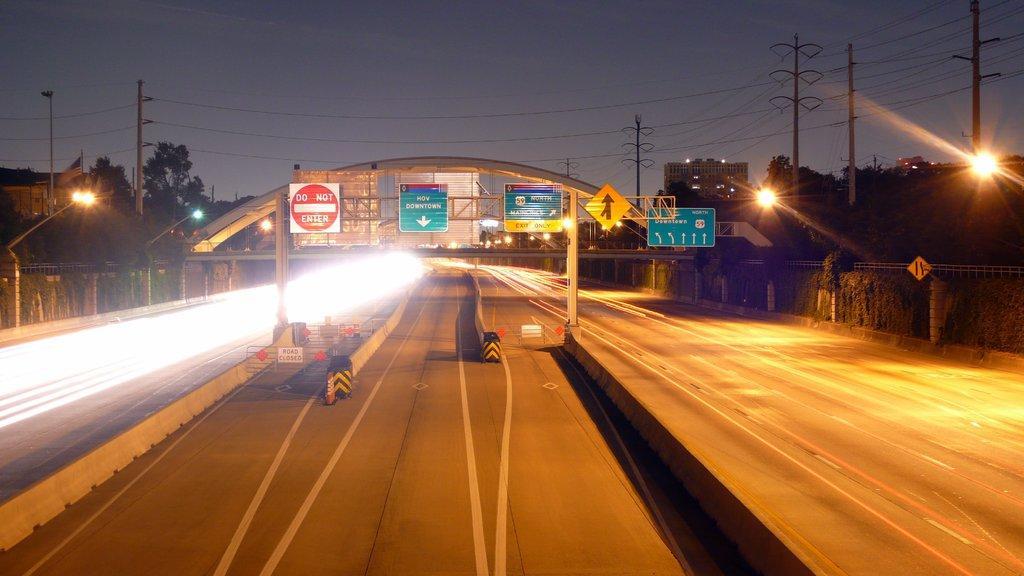In one or two sentences, can you explain what this image depicts? In this image we can see one big road, some safety poles on the road, some objects are on the surface, some small gates with boards, some boards with text attached to the iron rods, some sign boards, some lights with poles, some current poles with wires, some buildings, some trees, some plants, some flag with pole, some poles, one fence near to the road and at the top there is the sky. 